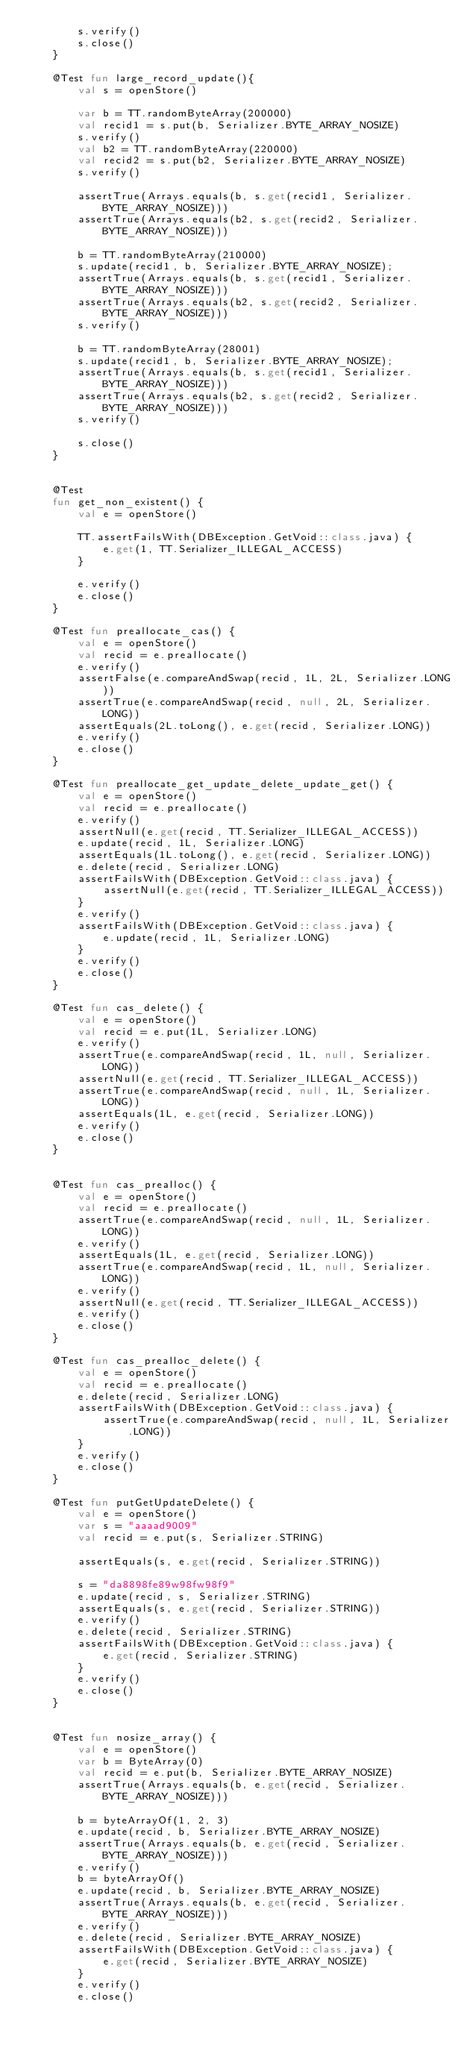<code> <loc_0><loc_0><loc_500><loc_500><_Kotlin_>        s.verify()
        s.close()
    }

    @Test fun large_record_update(){
        val s = openStore()

        var b = TT.randomByteArray(200000)
        val recid1 = s.put(b, Serializer.BYTE_ARRAY_NOSIZE)
        s.verify()
        val b2 = TT.randomByteArray(220000)
        val recid2 = s.put(b2, Serializer.BYTE_ARRAY_NOSIZE)
        s.verify()

        assertTrue(Arrays.equals(b, s.get(recid1, Serializer.BYTE_ARRAY_NOSIZE)))
        assertTrue(Arrays.equals(b2, s.get(recid2, Serializer.BYTE_ARRAY_NOSIZE)))

        b = TT.randomByteArray(210000)
        s.update(recid1, b, Serializer.BYTE_ARRAY_NOSIZE);
        assertTrue(Arrays.equals(b, s.get(recid1, Serializer.BYTE_ARRAY_NOSIZE)))
        assertTrue(Arrays.equals(b2, s.get(recid2, Serializer.BYTE_ARRAY_NOSIZE)))
        s.verify()

        b = TT.randomByteArray(28001)
        s.update(recid1, b, Serializer.BYTE_ARRAY_NOSIZE);
        assertTrue(Arrays.equals(b, s.get(recid1, Serializer.BYTE_ARRAY_NOSIZE)))
        assertTrue(Arrays.equals(b2, s.get(recid2, Serializer.BYTE_ARRAY_NOSIZE)))
        s.verify()

        s.close()
    }


    @Test
    fun get_non_existent() {
        val e = openStore()

        TT.assertFailsWith(DBException.GetVoid::class.java) {
            e.get(1, TT.Serializer_ILLEGAL_ACCESS)
        }

        e.verify()
        e.close()
    }

    @Test fun preallocate_cas() {
        val e = openStore()
        val recid = e.preallocate()
        e.verify()
        assertFalse(e.compareAndSwap(recid, 1L, 2L, Serializer.LONG))
        assertTrue(e.compareAndSwap(recid, null, 2L, Serializer.LONG))
        assertEquals(2L.toLong(), e.get(recid, Serializer.LONG))
        e.verify()
        e.close()
    }

    @Test fun preallocate_get_update_delete_update_get() {
        val e = openStore()
        val recid = e.preallocate()
        e.verify()
        assertNull(e.get(recid, TT.Serializer_ILLEGAL_ACCESS))
        e.update(recid, 1L, Serializer.LONG)
        assertEquals(1L.toLong(), e.get(recid, Serializer.LONG))
        e.delete(recid, Serializer.LONG)
        assertFailsWith(DBException.GetVoid::class.java) {
            assertNull(e.get(recid, TT.Serializer_ILLEGAL_ACCESS))
        }
        e.verify()
        assertFailsWith(DBException.GetVoid::class.java) {
            e.update(recid, 1L, Serializer.LONG)
        }
        e.verify()
        e.close()
    }

    @Test fun cas_delete() {
        val e = openStore()
        val recid = e.put(1L, Serializer.LONG)
        e.verify()
        assertTrue(e.compareAndSwap(recid, 1L, null, Serializer.LONG))
        assertNull(e.get(recid, TT.Serializer_ILLEGAL_ACCESS))
        assertTrue(e.compareAndSwap(recid, null, 1L, Serializer.LONG))
        assertEquals(1L, e.get(recid, Serializer.LONG))
        e.verify()
        e.close()
    }


    @Test fun cas_prealloc() {
        val e = openStore()
        val recid = e.preallocate()
        assertTrue(e.compareAndSwap(recid, null, 1L, Serializer.LONG))
        e.verify()
        assertEquals(1L, e.get(recid, Serializer.LONG))
        assertTrue(e.compareAndSwap(recid, 1L, null, Serializer.LONG))
        e.verify()
        assertNull(e.get(recid, TT.Serializer_ILLEGAL_ACCESS))
        e.verify()
        e.close()
    }

    @Test fun cas_prealloc_delete() {
        val e = openStore()
        val recid = e.preallocate()
        e.delete(recid, Serializer.LONG)
        assertFailsWith(DBException.GetVoid::class.java) {
            assertTrue(e.compareAndSwap(recid, null, 1L, Serializer.LONG))
        }
        e.verify()
        e.close()
    }

    @Test fun putGetUpdateDelete() {
        val e = openStore()
        var s = "aaaad9009"
        val recid = e.put(s, Serializer.STRING)

        assertEquals(s, e.get(recid, Serializer.STRING))

        s = "da8898fe89w98fw98f9"
        e.update(recid, s, Serializer.STRING)
        assertEquals(s, e.get(recid, Serializer.STRING))
        e.verify()
        e.delete(recid, Serializer.STRING)
        assertFailsWith(DBException.GetVoid::class.java) {
            e.get(recid, Serializer.STRING)
        }
        e.verify()
        e.close()
    }


    @Test fun nosize_array() {
        val e = openStore()
        var b = ByteArray(0)
        val recid = e.put(b, Serializer.BYTE_ARRAY_NOSIZE)
        assertTrue(Arrays.equals(b, e.get(recid, Serializer.BYTE_ARRAY_NOSIZE)))

        b = byteArrayOf(1, 2, 3)
        e.update(recid, b, Serializer.BYTE_ARRAY_NOSIZE)
        assertTrue(Arrays.equals(b, e.get(recid, Serializer.BYTE_ARRAY_NOSIZE)))
        e.verify()
        b = byteArrayOf()
        e.update(recid, b, Serializer.BYTE_ARRAY_NOSIZE)
        assertTrue(Arrays.equals(b, e.get(recid, Serializer.BYTE_ARRAY_NOSIZE)))
        e.verify()
        e.delete(recid, Serializer.BYTE_ARRAY_NOSIZE)
        assertFailsWith(DBException.GetVoid::class.java) {
            e.get(recid, Serializer.BYTE_ARRAY_NOSIZE)
        }
        e.verify()
        e.close()</code> 